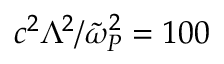<formula> <loc_0><loc_0><loc_500><loc_500>c ^ { 2 } \Lambda ^ { 2 } / \tilde { \omega } _ { P } ^ { 2 } = 1 0 0</formula> 